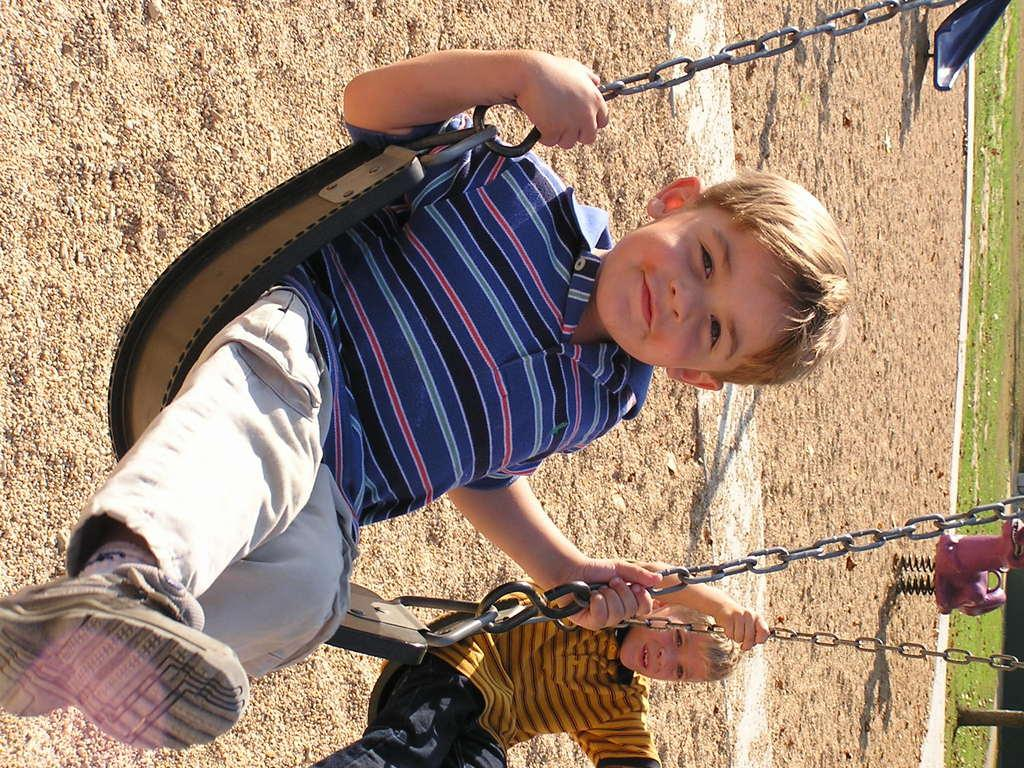How many boys are in the foreground of the picture? There are two boys in the foreground of the picture. What are the boys doing in the image? The boys are swinging on a swing chair. Where does the scene take place? The scene takes place in a park. What type of surface can be seen in the background of the image? There is sand in the background of the image. What playground equipment is visible in the background of the image? There is a slide in the background of the image. What type of vegetation is present in the background of the image? There is grass in the background of the image. How many flowers are in the image? There are no flowers visible in the image. What type of group is shown in the image? There is no group present in the image; it features two individual boys. 